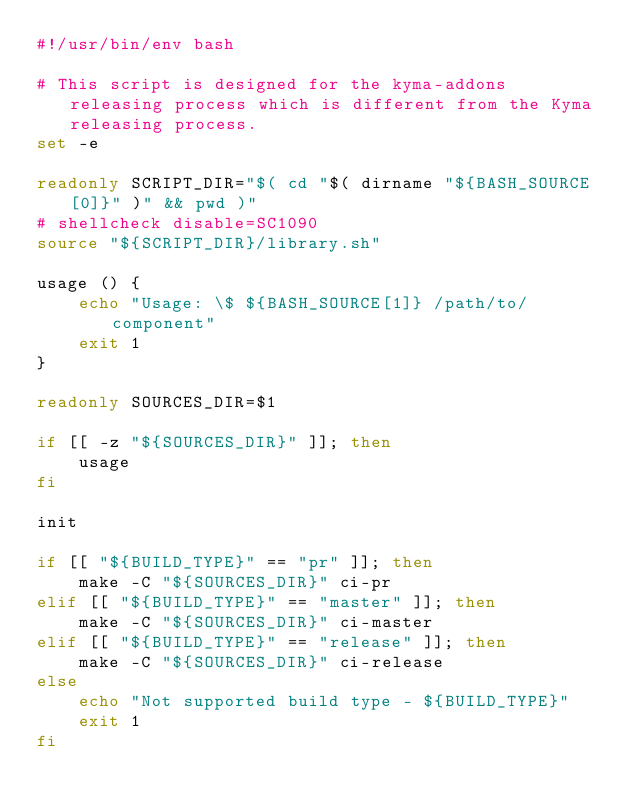<code> <loc_0><loc_0><loc_500><loc_500><_Bash_>#!/usr/bin/env bash

# This script is designed for the kyma-addons releasing process which is different from the Kyma releasing process.
set -e

readonly SCRIPT_DIR="$( cd "$( dirname "${BASH_SOURCE[0]}" )" && pwd )"
# shellcheck disable=SC1090
source "${SCRIPT_DIR}/library.sh"

usage () {
    echo "Usage: \$ ${BASH_SOURCE[1]} /path/to/component"
    exit 1
}

readonly SOURCES_DIR=$1

if [[ -z "${SOURCES_DIR}" ]]; then
    usage
fi

init

if [[ "${BUILD_TYPE}" == "pr" ]]; then
    make -C "${SOURCES_DIR}" ci-pr
elif [[ "${BUILD_TYPE}" == "master" ]]; then
    make -C "${SOURCES_DIR}" ci-master
elif [[ "${BUILD_TYPE}" == "release" ]]; then
    make -C "${SOURCES_DIR}" ci-release
else
    echo "Not supported build type - ${BUILD_TYPE}"
    exit 1
fi</code> 